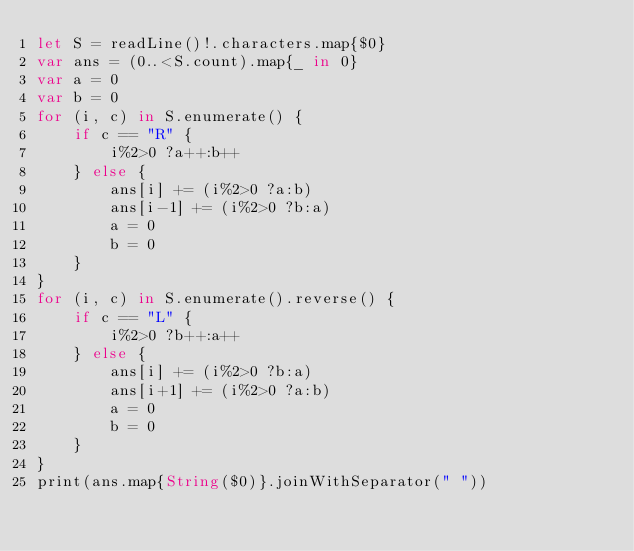<code> <loc_0><loc_0><loc_500><loc_500><_Swift_>let S = readLine()!.characters.map{$0}
var ans = (0..<S.count).map{_ in 0}
var a = 0
var b = 0
for (i, c) in S.enumerate() {
    if c == "R" {
        i%2>0 ?a++:b++
    } else {
        ans[i] += (i%2>0 ?a:b)
        ans[i-1] += (i%2>0 ?b:a)
        a = 0
        b = 0
    }
}
for (i, c) in S.enumerate().reverse() {
    if c == "L" {
        i%2>0 ?b++:a++
    } else {
        ans[i] += (i%2>0 ?b:a)
        ans[i+1] += (i%2>0 ?a:b)
        a = 0
        b = 0
    }
}
print(ans.map{String($0)}.joinWithSeparator(" "))</code> 